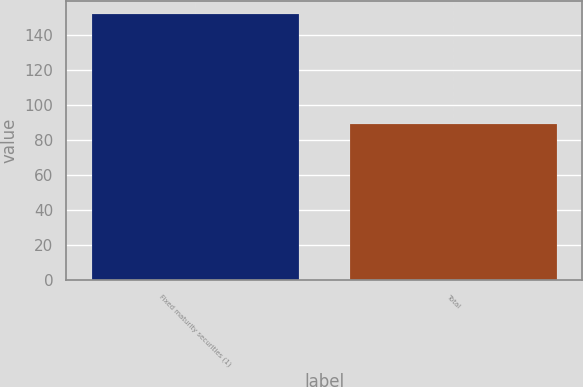<chart> <loc_0><loc_0><loc_500><loc_500><bar_chart><fcel>Fixed maturity securities (1)<fcel>Total<nl><fcel>151.8<fcel>89<nl></chart> 